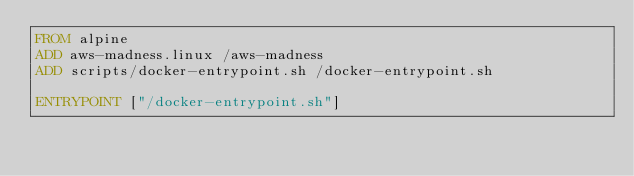Convert code to text. <code><loc_0><loc_0><loc_500><loc_500><_Dockerfile_>FROM alpine
ADD aws-madness.linux /aws-madness
ADD scripts/docker-entrypoint.sh /docker-entrypoint.sh

ENTRYPOINT ["/docker-entrypoint.sh"]
</code> 